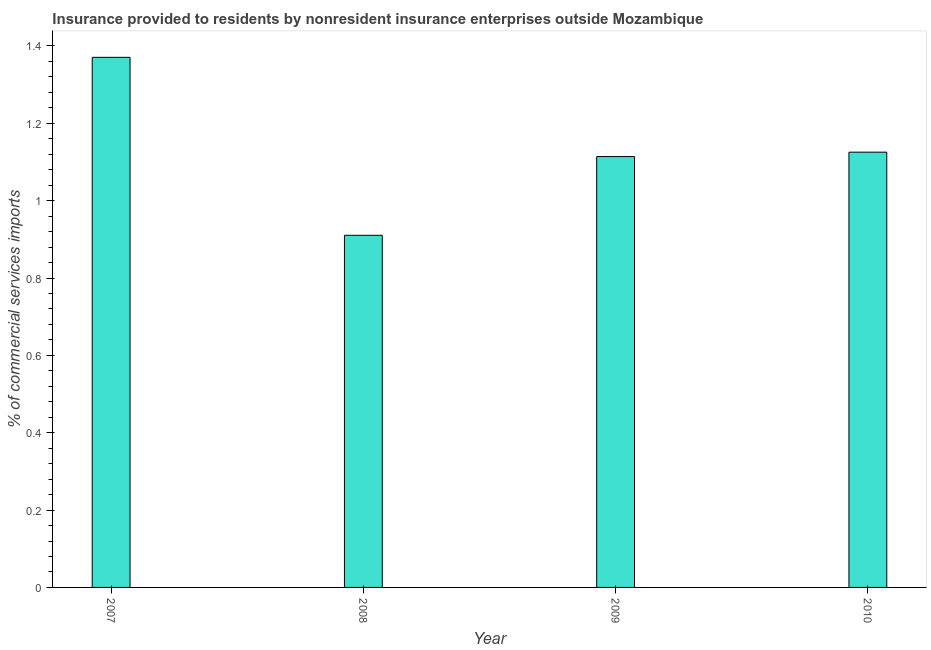Does the graph contain grids?
Your response must be concise. No. What is the title of the graph?
Your answer should be very brief. Insurance provided to residents by nonresident insurance enterprises outside Mozambique. What is the label or title of the Y-axis?
Offer a very short reply. % of commercial services imports. What is the insurance provided by non-residents in 2008?
Ensure brevity in your answer.  0.91. Across all years, what is the maximum insurance provided by non-residents?
Make the answer very short. 1.37. Across all years, what is the minimum insurance provided by non-residents?
Offer a terse response. 0.91. In which year was the insurance provided by non-residents maximum?
Provide a short and direct response. 2007. In which year was the insurance provided by non-residents minimum?
Provide a succinct answer. 2008. What is the sum of the insurance provided by non-residents?
Your answer should be very brief. 4.52. What is the difference between the insurance provided by non-residents in 2008 and 2010?
Your response must be concise. -0.21. What is the average insurance provided by non-residents per year?
Provide a short and direct response. 1.13. What is the median insurance provided by non-residents?
Provide a short and direct response. 1.12. In how many years, is the insurance provided by non-residents greater than 0.88 %?
Your answer should be compact. 4. What is the ratio of the insurance provided by non-residents in 2007 to that in 2009?
Give a very brief answer. 1.23. Is the insurance provided by non-residents in 2009 less than that in 2010?
Ensure brevity in your answer.  Yes. Is the difference between the insurance provided by non-residents in 2008 and 2010 greater than the difference between any two years?
Ensure brevity in your answer.  No. What is the difference between the highest and the second highest insurance provided by non-residents?
Provide a succinct answer. 0.24. Is the sum of the insurance provided by non-residents in 2007 and 2008 greater than the maximum insurance provided by non-residents across all years?
Your answer should be very brief. Yes. What is the difference between the highest and the lowest insurance provided by non-residents?
Your answer should be very brief. 0.46. How many bars are there?
Offer a terse response. 4. How many years are there in the graph?
Offer a very short reply. 4. Are the values on the major ticks of Y-axis written in scientific E-notation?
Provide a succinct answer. No. What is the % of commercial services imports of 2007?
Your answer should be very brief. 1.37. What is the % of commercial services imports of 2008?
Give a very brief answer. 0.91. What is the % of commercial services imports of 2009?
Ensure brevity in your answer.  1.11. What is the % of commercial services imports in 2010?
Offer a terse response. 1.13. What is the difference between the % of commercial services imports in 2007 and 2008?
Offer a terse response. 0.46. What is the difference between the % of commercial services imports in 2007 and 2009?
Make the answer very short. 0.26. What is the difference between the % of commercial services imports in 2007 and 2010?
Provide a short and direct response. 0.25. What is the difference between the % of commercial services imports in 2008 and 2009?
Provide a succinct answer. -0.2. What is the difference between the % of commercial services imports in 2008 and 2010?
Provide a succinct answer. -0.21. What is the difference between the % of commercial services imports in 2009 and 2010?
Ensure brevity in your answer.  -0.01. What is the ratio of the % of commercial services imports in 2007 to that in 2008?
Your response must be concise. 1.5. What is the ratio of the % of commercial services imports in 2007 to that in 2009?
Keep it short and to the point. 1.23. What is the ratio of the % of commercial services imports in 2007 to that in 2010?
Your response must be concise. 1.22. What is the ratio of the % of commercial services imports in 2008 to that in 2009?
Ensure brevity in your answer.  0.82. What is the ratio of the % of commercial services imports in 2008 to that in 2010?
Provide a succinct answer. 0.81. What is the ratio of the % of commercial services imports in 2009 to that in 2010?
Offer a very short reply. 0.99. 